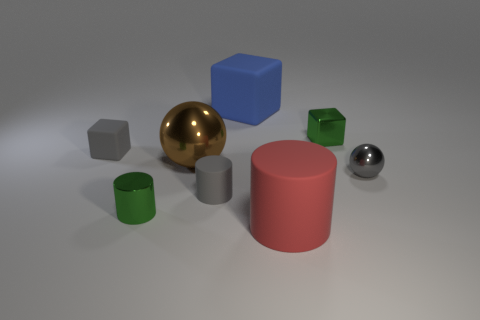What material is the big red thing?
Your answer should be very brief. Rubber. What is the shape of the blue object?
Provide a succinct answer. Cube. How many metal cylinders are the same color as the small shiny cube?
Offer a very short reply. 1. What material is the tiny cube that is in front of the small green metallic object that is to the right of the green thing in front of the small shiny sphere made of?
Offer a terse response. Rubber. How many yellow things are either cylinders or big metallic balls?
Ensure brevity in your answer.  0. There is a object on the right side of the small green metallic thing right of the tiny green shiny object that is on the left side of the blue rubber cube; how big is it?
Provide a short and direct response. Small. There is a gray metal object that is the same shape as the large brown thing; what is its size?
Your response must be concise. Small. How many small things are green shiny blocks or yellow shiny balls?
Make the answer very short. 1. Is the small green thing in front of the brown metal object made of the same material as the small green thing that is to the right of the big matte cylinder?
Give a very brief answer. Yes. There is a large red cylinder that is on the right side of the tiny matte cube; what material is it?
Your answer should be compact. Rubber. 